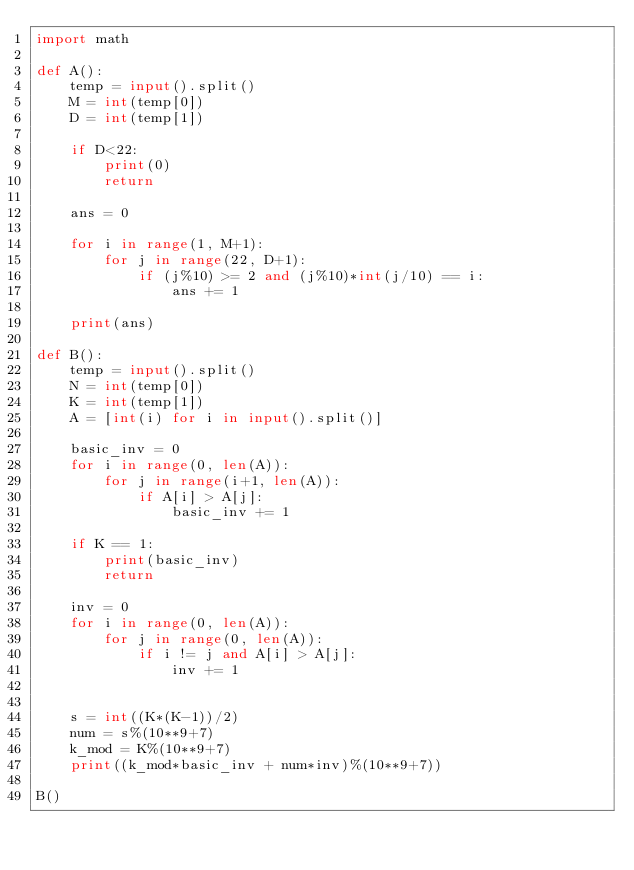<code> <loc_0><loc_0><loc_500><loc_500><_Python_>import math

def A():
    temp = input().split()
    M = int(temp[0])
    D = int(temp[1])

    if D<22:
        print(0)
        return
    
    ans = 0

    for i in range(1, M+1):
        for j in range(22, D+1):
            if (j%10) >= 2 and (j%10)*int(j/10) == i:
                ans += 1
    
    print(ans)

def B():
    temp = input().split()
    N = int(temp[0])
    K = int(temp[1])
    A = [int(i) for i in input().split()]

    basic_inv = 0
    for i in range(0, len(A)):
        for j in range(i+1, len(A)):
            if A[i] > A[j]:
                basic_inv += 1
    
    if K == 1:
        print(basic_inv)
        return

    inv = 0
    for i in range(0, len(A)):
        for j in range(0, len(A)):
            if i != j and A[i] > A[j]:
                inv += 1

    
    s = int((K*(K-1))/2)
    num = s%(10**9+7)
    k_mod = K%(10**9+7)
    print((k_mod*basic_inv + num*inv)%(10**9+7))

B()

</code> 